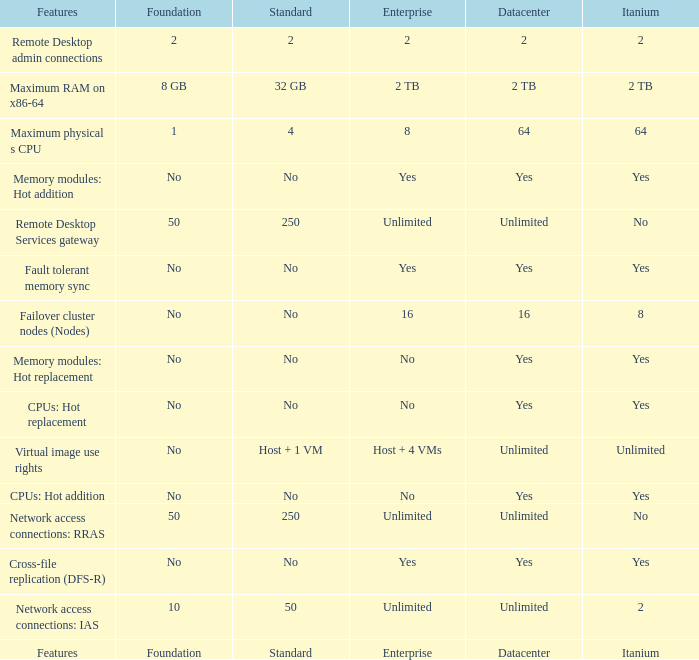Which Features have Yes listed under Datacenter? Cross-file replication (DFS-R), Fault tolerant memory sync, Memory modules: Hot addition, Memory modules: Hot replacement, CPUs: Hot addition, CPUs: Hot replacement. 